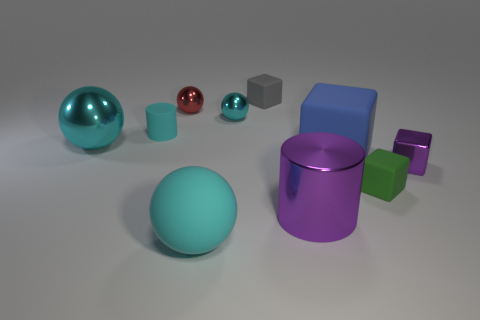Is the small metal block the same color as the large cylinder?
Offer a very short reply. Yes. How many other objects are the same shape as the tiny cyan metal object?
Your answer should be compact. 3. What material is the small cylinder that is the same color as the large rubber ball?
Ensure brevity in your answer.  Rubber. How many small balls are the same color as the matte cylinder?
Your answer should be compact. 1. Do the cylinder that is in front of the tiny cylinder and the metallic object right of the purple metallic cylinder have the same color?
Make the answer very short. Yes. What material is the large blue object?
Your answer should be compact. Rubber. How big is the purple metallic thing on the left side of the big matte block?
Your response must be concise. Large. Are there any other things that are the same color as the large shiny cylinder?
Keep it short and to the point. Yes. Is there a large cyan shiny object that is left of the gray rubber cube behind the purple shiny thing that is left of the small purple metal object?
Your answer should be very brief. Yes. Is the color of the ball to the left of the cyan matte cylinder the same as the rubber ball?
Offer a very short reply. Yes. 